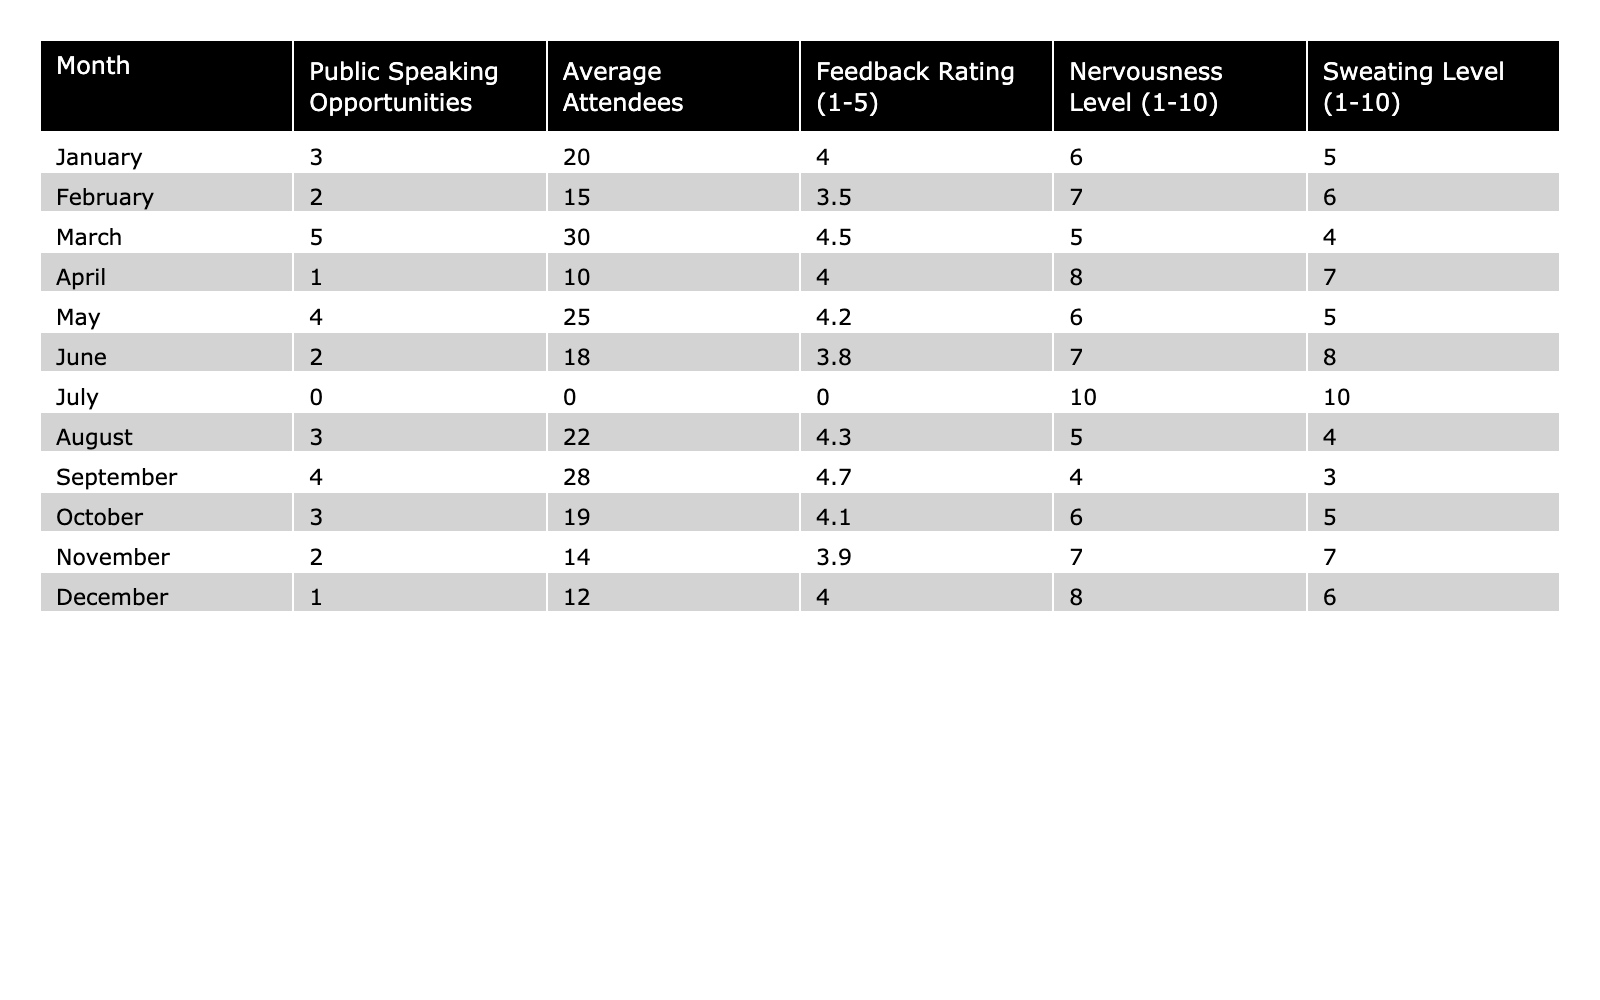What month had the highest number of public speaking opportunities? January had the highest number with 3 opportunities. Looking at each month, I see the maximum value in the "Public Speaking Opportunities" column for January is 3.
Answer: January What is the average feedback rating for public speaking opportunities throughout the year? To calculate the average, I sum all the feedback ratings (4.0 + 3.5 + 4.5 + 4.0 + 4.2 + 3.8 + 0 + 4.3 + 4.7 + 4.1 + 3.9 + 4.0 = 50.0) and divide by the number of months (12). Hence, 50.0 / 12 = 4.17.
Answer: 4.17 Was there a month with no public speaking opportunities? Yes, July had 0 public speaking opportunities. I can see from the table that July's entry in the "Public Speaking Opportunities" column is 0.
Answer: Yes What month experienced the highest nervousness level? April had the highest nervousness level at 8. Reviewing the "Nervousness Level" column, I find the maximum value is 8, corresponding to April.
Answer: April What is the combined total of public speaking opportunities from May to August? I add the public speaking opportunities for May (4), June (2), July (0), and August (3). So 4 + 2 + 0 + 3 = 9.
Answer: 9 Which month had the lowest sweating level and what was that level? September had the lowest sweating level of 3. In the "Sweating Level" column, September's entry is the minimum at 3.
Answer: 3 How does the average number of attendees compare between the first half and the second half of the year? I first find the average number of attendees for the first half (January to June) which is (20 + 15 + 30 + 10 + 25 + 18) / 6 = 18. The second half (July to December) is (0 + 22 + 28 + 19 + 14 + 12) / 6 = 14.7. Comparing 18 and 14.7, the first half has more attendees on average.
Answer: The first half has more attendees What was the highest feedback rating recorded and in which month did it occur? The highest feedback rating was 4.7 in September. I can see this in the "Feedback Rating" column, where September has the highest value.
Answer: 4.7 in September Is the sweating level higher or lower in June compared to the month with the highest public speaking opportunities? The sweating level in June is 8, while the month with the highest opportunities (March) has a sweating level of 4. Since 8 is greater than 4, the sweating level in June is higher.
Answer: Higher 